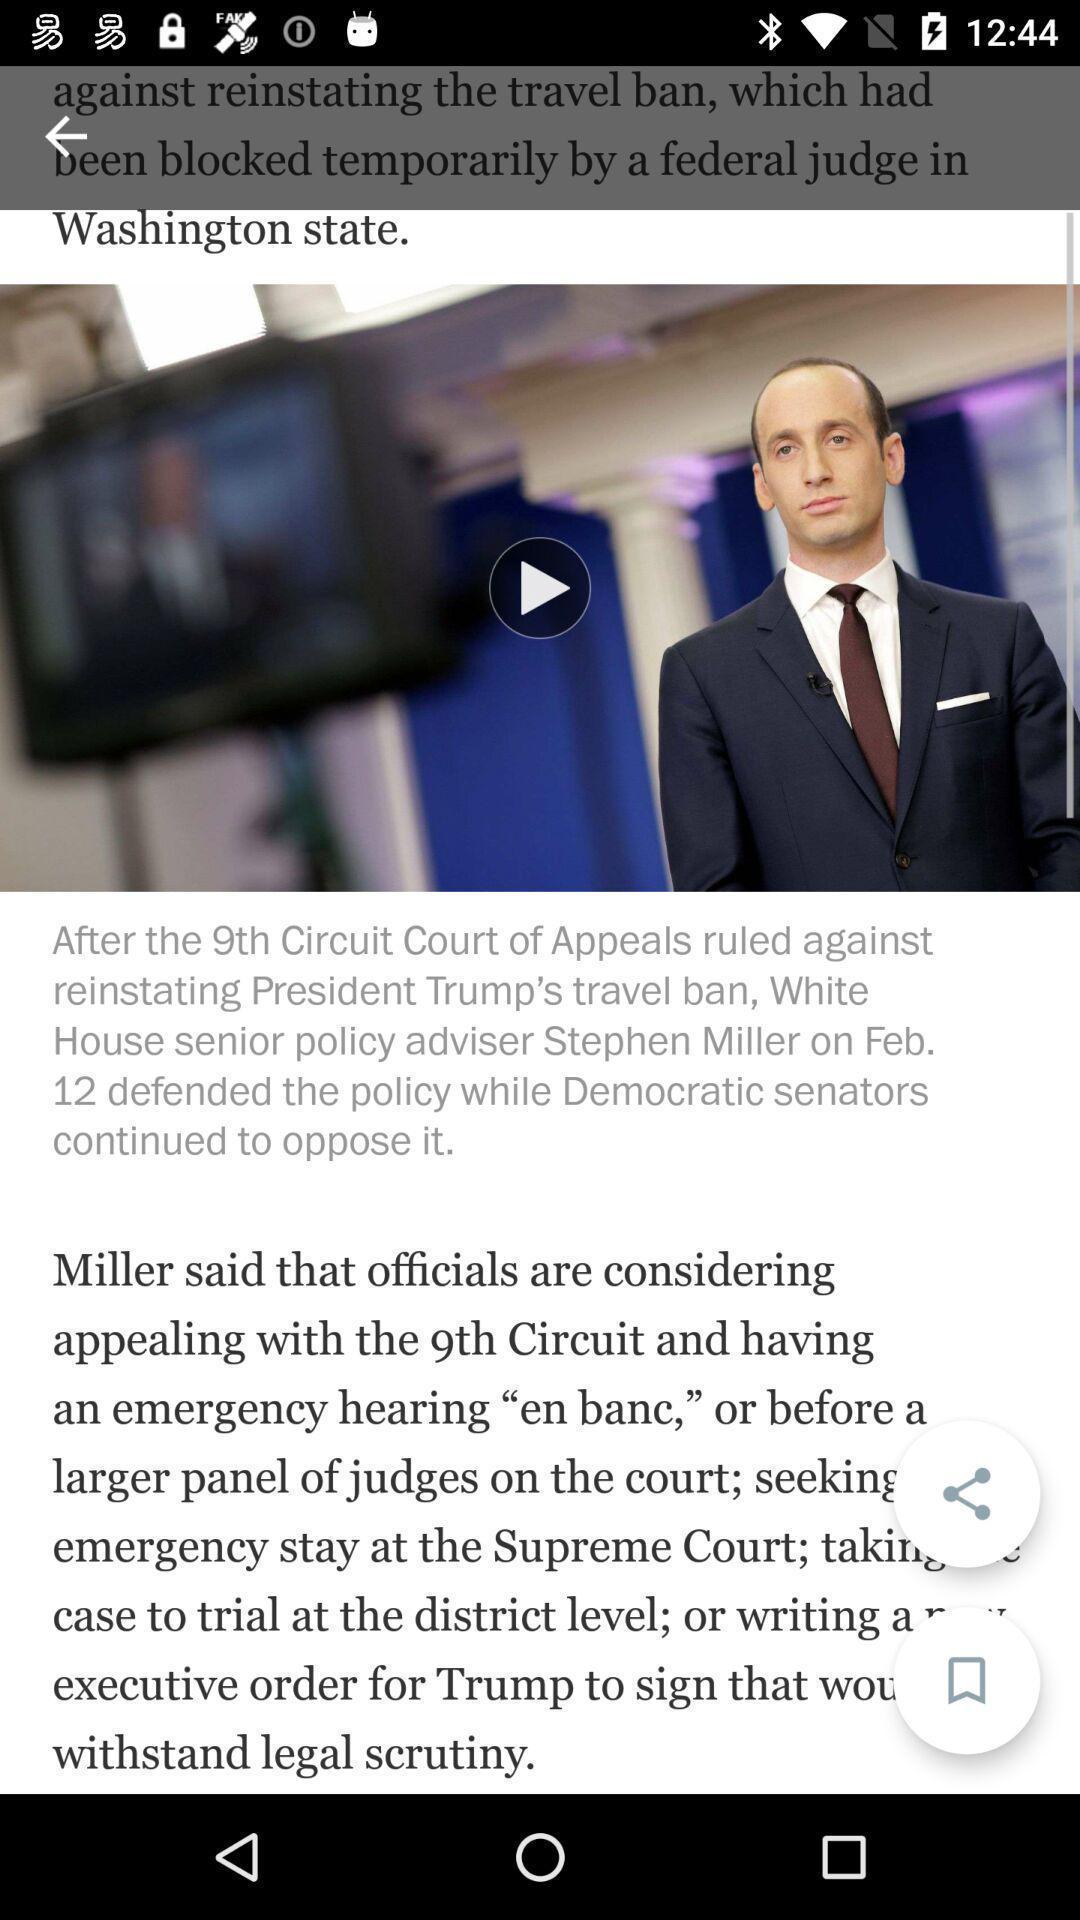Give me a summary of this screen capture. Video of news in news app. 